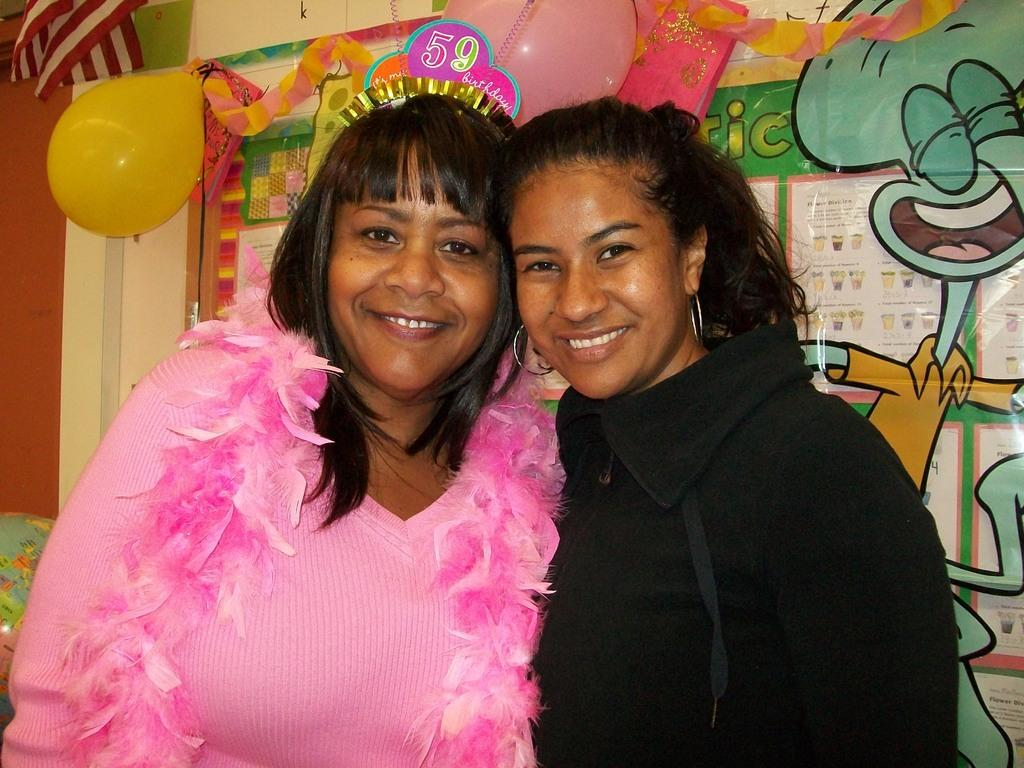How many girls are in the image? There are two girls in the middle of the image. What can be seen in the background of the image? There are balloons and other decorative items on the wall in the background of the image. What type of thought can be seen on the girls' faces in the image? There is no indication of the girls' thoughts in the image, as facial expressions cannot convey thoughts directly. 